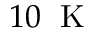Convert formula to latex. <formula><loc_0><loc_0><loc_500><loc_500>1 0 \, K</formula> 